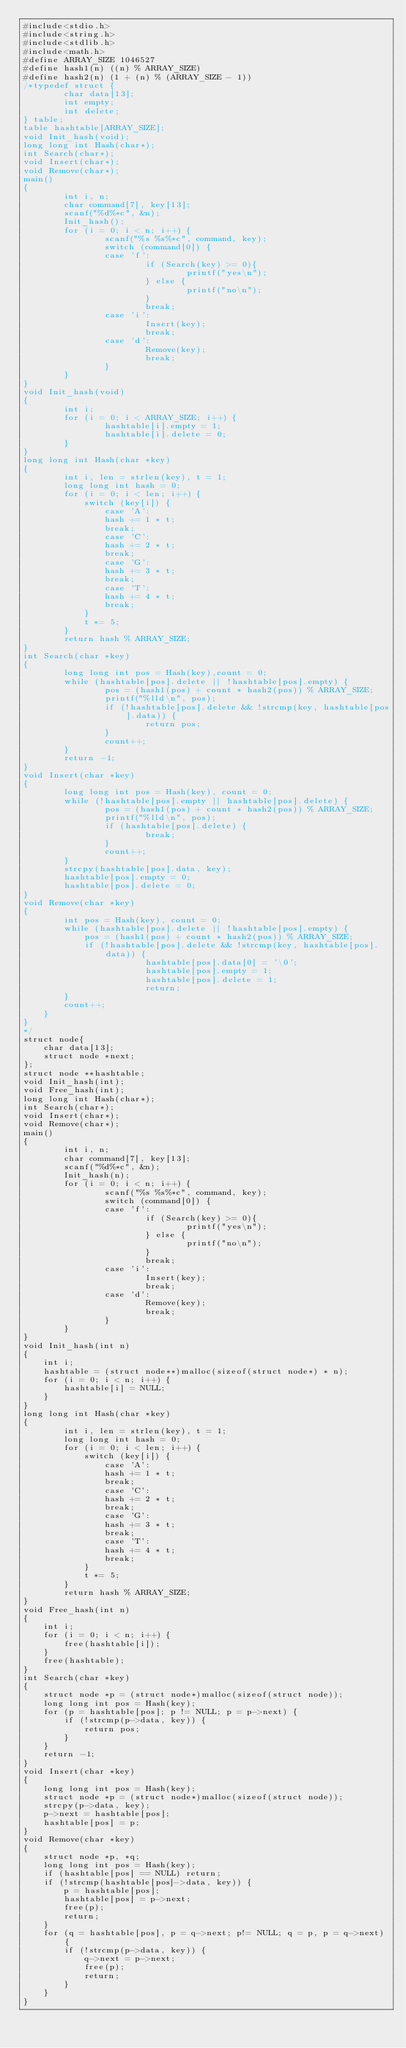<code> <loc_0><loc_0><loc_500><loc_500><_C_>#include<stdio.h>
#include<string.h>
#include<stdlib.h>
#include<math.h>
#define ARRAY_SIZE 1046527
#define hash1(n) ((n) % ARRAY_SIZE)
#define hash2(n) (1 + (n) % (ARRAY_SIZE - 1))
/*typedef struct {
        char data[13];
        int empty;
        int delete;
} table;
table hashtable[ARRAY_SIZE];
void Init_hash(void);
long long int Hash(char*);
int Search(char*);
void Insert(char*);
void Remove(char*);
main()
{
        int i, n;
        char command[7], key[13];
        scanf("%d%*c", &n);
        Init_hash();
        for (i = 0; i < n; i++) {
                scanf("%s %s%*c", command, key);
                switch (command[0]) {
                case 'f':
                        if (Search(key) >= 0){
                                printf("yes\n");
                        } else {
                                printf("no\n");
                        }
                        break;
                case 'i':
                        Insert(key);
                        break;
                case 'd':
                        Remove(key);
                        break;
                }
        }
}
void Init_hash(void)
{
        int i;
        for (i = 0; i < ARRAY_SIZE; i++) {
                hashtable[i].empty = 1;
                hashtable[i].delete = 0;
        }
}
long long int Hash(char *key)
{
        int i, len = strlen(key), t = 1;
        long long int hash = 0;
        for (i = 0; i < len; i++) {
        	switch (key[i]) {
        		case 'A':
        		hash += 1 * t;
        		break;
        		case 'C':
        		hash += 2 * t;
        		break;
        		case 'G':
        		hash += 3 * t;
        		break;
        		case 'T':
        		hash += 4 * t;
        		break;
        	}
            t *= 5;
        }
        return hash % ARRAY_SIZE;
}
int Search(char *key)
{
        long long int pos = Hash(key),count = 0;
        while (hashtable[pos].delete || !hashtable[pos].empty) {
        		pos = (hash1(pos) + count * hash2(pos)) % ARRAY_SIZE;
        		printf("%lld\n", pos);
                if (!hashtable[pos].delete && !strcmp(key, hashtable[pos].data)) {
                        return pos;
                }
                count++;
        }
        return -1;
}
void Insert(char *key)
{
        long long int pos = Hash(key), count = 0;
        while (!hashtable[pos].empty || hashtable[pos].delete) {
        		pos = (hash1(pos) + count * hash2(pos)) % ARRAY_SIZE;
        		printf("%lld\n", pos);
                if (hashtable[pos].delete) {
                        break;
                }
                count++;
        }
        strcpy(hashtable[pos].data, key);
        hashtable[pos].empty = 0;
        hashtable[pos].delete = 0;
}
void Remove(char *key)
{
        int pos = Hash(key), count = 0;
        while (hashtable[pos].delete || !hashtable[pos].empty) {
        	pos = (hash1(pos) + count * hash2(pos)) % ARRAY_SIZE;
        	if (!hashtable[pos].delete && !strcmp(key, hashtable[pos].data)) {
                        hashtable[pos].data[0] = '\0';
                        hashtable[pos].empty = 1;
                        hashtable[pos].delete = 1;
                        return;
        }
        count++;
    }
}
*/
struct node{
	char data[13];
	struct node *next; 
};
struct node **hashtable;
void Init_hash(int);
void Free_hash(int);
long long int Hash(char*);
int Search(char*);
void Insert(char*);
void Remove(char*);
main()
{
        int i, n;
        char command[7], key[13];
        scanf("%d%*c", &n);
        Init_hash(n);
        for (i = 0; i < n; i++) {
                scanf("%s %s%*c", command, key);
                switch (command[0]) {
                case 'f':
                        if (Search(key) >= 0){
                                printf("yes\n");
                        } else {
                                printf("no\n");
                        }
                        break;
                case 'i':
                        Insert(key);
                        break;
                case 'd':
                        Remove(key);
                        break;
                }
        }
}
void Init_hash(int n)
{
	int i;
	hashtable = (struct node**)malloc(sizeof(struct node*) * n);
	for (i = 0; i < n; i++) {
		hashtable[i] = NULL;
	}
}
long long int Hash(char *key)
{
        int i, len = strlen(key), t = 1;
        long long int hash = 0;
        for (i = 0; i < len; i++) {
        	switch (key[i]) {
        		case 'A':
        		hash += 1 * t;
        		break;
        		case 'C':
        		hash += 2 * t;
        		break;
        		case 'G':
        		hash += 3 * t;
        		break;
        		case 'T':
        		hash += 4 * t;
        		break;
        	}
            t *= 5;
        }
        return hash % ARRAY_SIZE;
} 
void Free_hash(int n)
{
	int i;
	for (i = 0; i < n; i++) {
		free(hashtable[i]);
	}
	free(hashtable);
}
int Search(char *key)
{
	struct node *p = (struct node*)malloc(sizeof(struct node));
    long long int pos = Hash(key);
    for (p = hashtable[pos]; p != NULL; p = p->next) {
    	if (!strcmp(p->data, key)) {
    		return pos;
    	}
    }
    return -1;
}
void Insert(char *key)
{
	long long int pos = Hash(key);
	struct node *p = (struct node*)malloc(sizeof(struct node));   
    strcpy(p->data, key);
    p->next = hashtable[pos];
    hashtable[pos] = p;
}
void Remove(char *key)
{
	struct node *p, *q;
	long long int pos = Hash(key);
	if (hashtable[pos] == NULL) return;
	if (!strcmp(hashtable[pos]->data, key)) {
		p = hashtable[pos];
		hashtable[pos] = p->next;
		free(p);
		return;
	}
	for (q = hashtable[pos], p = q->next; p!= NULL; q = p, p = q->next) {
		if (!strcmp(p->data, key)) {
			q->next = p->next;
			free(p);
			return;
		}
	}
}
</code> 